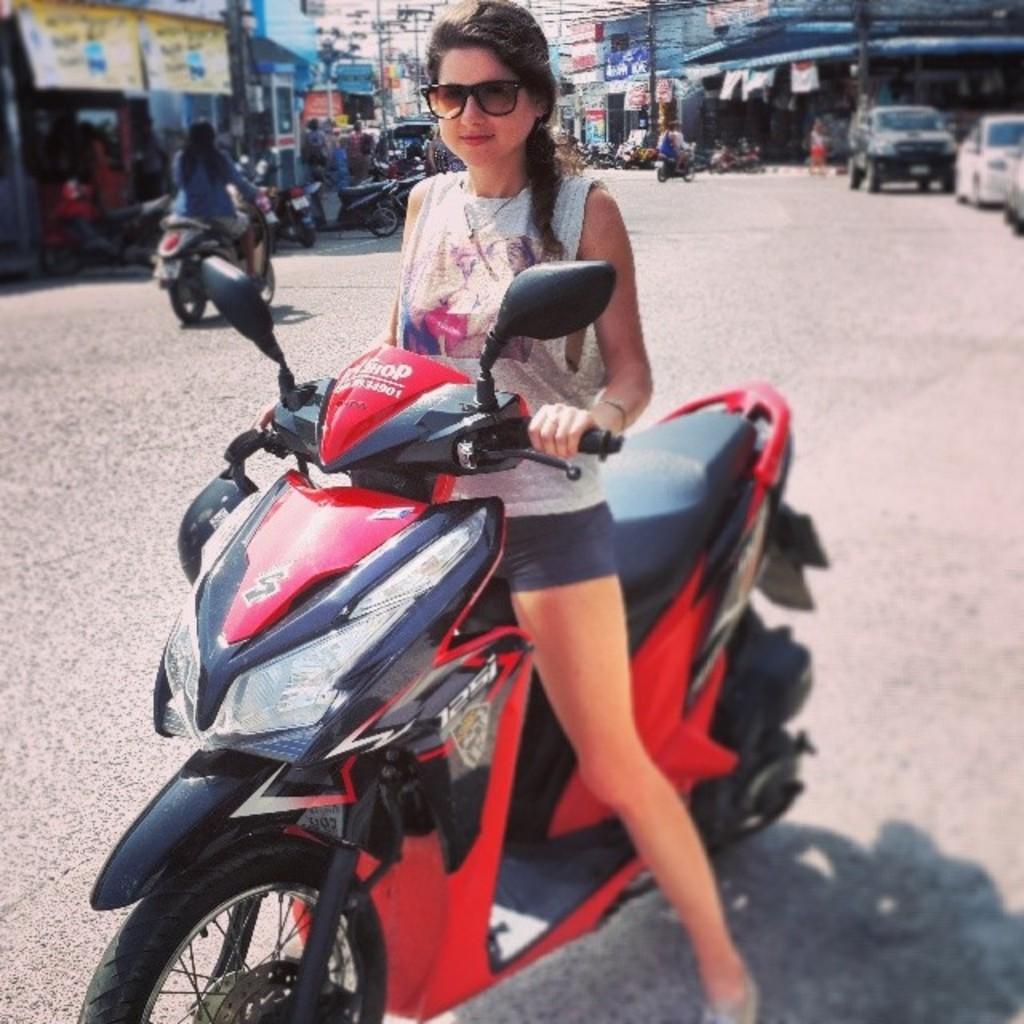In one or two sentences, can you explain what this image depicts? In the image we can see there is a woman who is sitting on scooty and on the back people are sitting on the bikes and vehicles. Cars are parked at the back. 